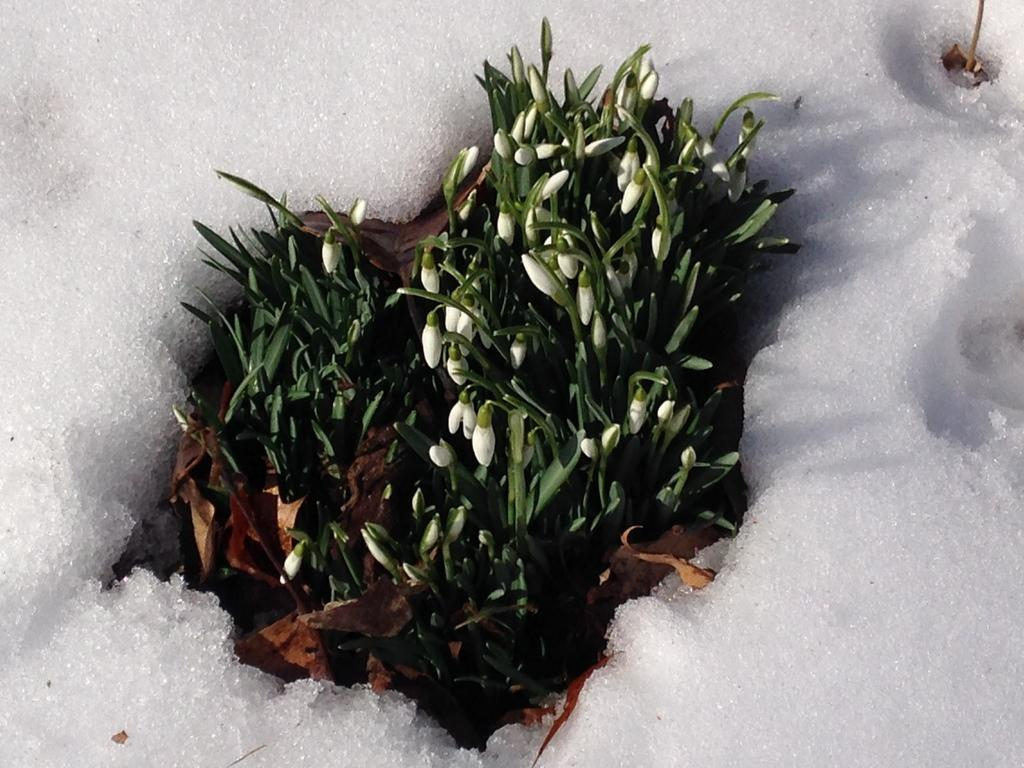What type of plant is depicted in the image? The image contains white flower buds and green leaves. Can you describe the color of the flower buds? The flower buds in the image are white. What other part of the plant can be seen in the image? There are green leaves in the image. What type of hobbies can be seen being practiced in the image? There are no hobbies depicted in the image; it features white flower buds and green leaves. What type of wine is being served in the image? There is no wine present in the image; it features white flower buds and green leaves. 